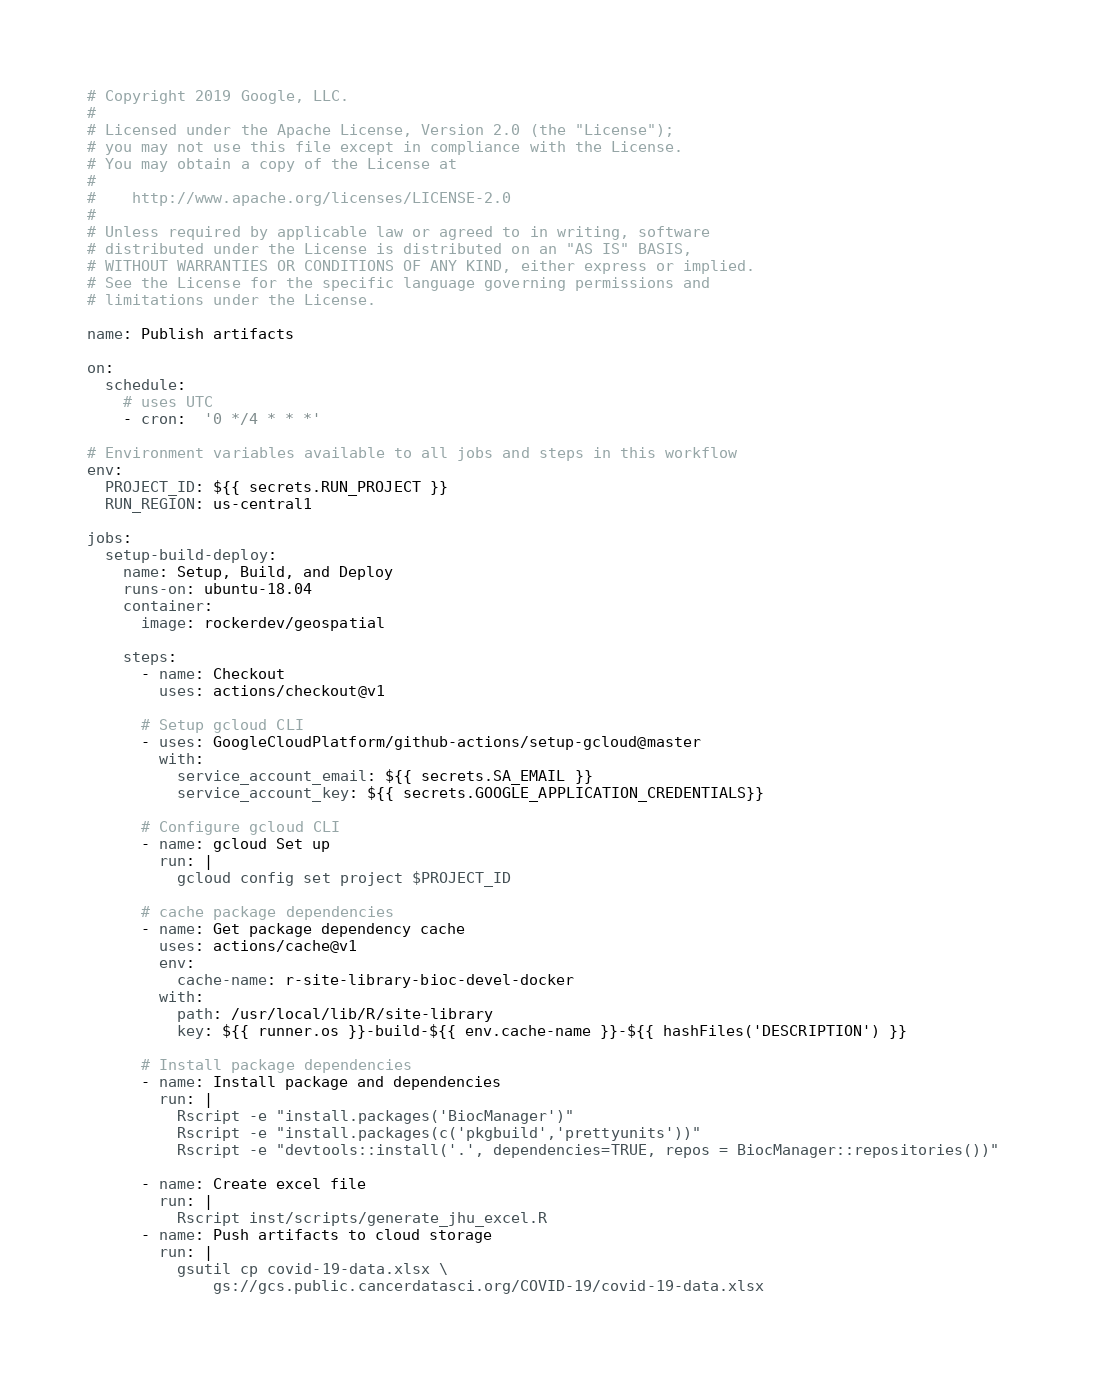<code> <loc_0><loc_0><loc_500><loc_500><_YAML_># Copyright 2019 Google, LLC.
#
# Licensed under the Apache License, Version 2.0 (the "License");
# you may not use this file except in compliance with the License.
# You may obtain a copy of the License at
#
#    http://www.apache.org/licenses/LICENSE-2.0
#
# Unless required by applicable law or agreed to in writing, software
# distributed under the License is distributed on an "AS IS" BASIS,
# WITHOUT WARRANTIES OR CONDITIONS OF ANY KIND, either express or implied.
# See the License for the specific language governing permissions and
# limitations under the License.

name: Publish artifacts

on:
  schedule:
    # uses UTC
    - cron:  '0 */4 * * *'

# Environment variables available to all jobs and steps in this workflow
env:
  PROJECT_ID: ${{ secrets.RUN_PROJECT }}
  RUN_REGION: us-central1

jobs:
  setup-build-deploy:
    name: Setup, Build, and Deploy
    runs-on: ubuntu-18.04
    container:
      image: rockerdev/geospatial

    steps:
      - name: Checkout
        uses: actions/checkout@v1

      # Setup gcloud CLI
      - uses: GoogleCloudPlatform/github-actions/setup-gcloud@master
        with:
          service_account_email: ${{ secrets.SA_EMAIL }}
          service_account_key: ${{ secrets.GOOGLE_APPLICATION_CREDENTIALS}}

      # Configure gcloud CLI
      - name: gcloud Set up
        run: |
          gcloud config set project $PROJECT_ID

      # cache package dependencies
      - name: Get package dependency cache
        uses: actions/cache@v1
        env:
          cache-name: r-site-library-bioc-devel-docker
        with:
          path: /usr/local/lib/R/site-library
          key: ${{ runner.os }}-build-${{ env.cache-name }}-${{ hashFiles('DESCRIPTION') }}
      
      # Install package dependencies
      - name: Install package and dependencies
        run: |
          Rscript -e "install.packages('BiocManager')"
          Rscript -e "install.packages(c('pkgbuild','prettyunits'))"
          Rscript -e "devtools::install('.', dependencies=TRUE, repos = BiocManager::repositories())" 

      - name: Create excel file
        run: |
          Rscript inst/scripts/generate_jhu_excel.R
      - name: Push artifacts to cloud storage
        run: |
          gsutil cp covid-19-data.xlsx \
              gs://gcs.public.cancerdatasci.org/COVID-19/covid-19-data.xlsx
</code> 